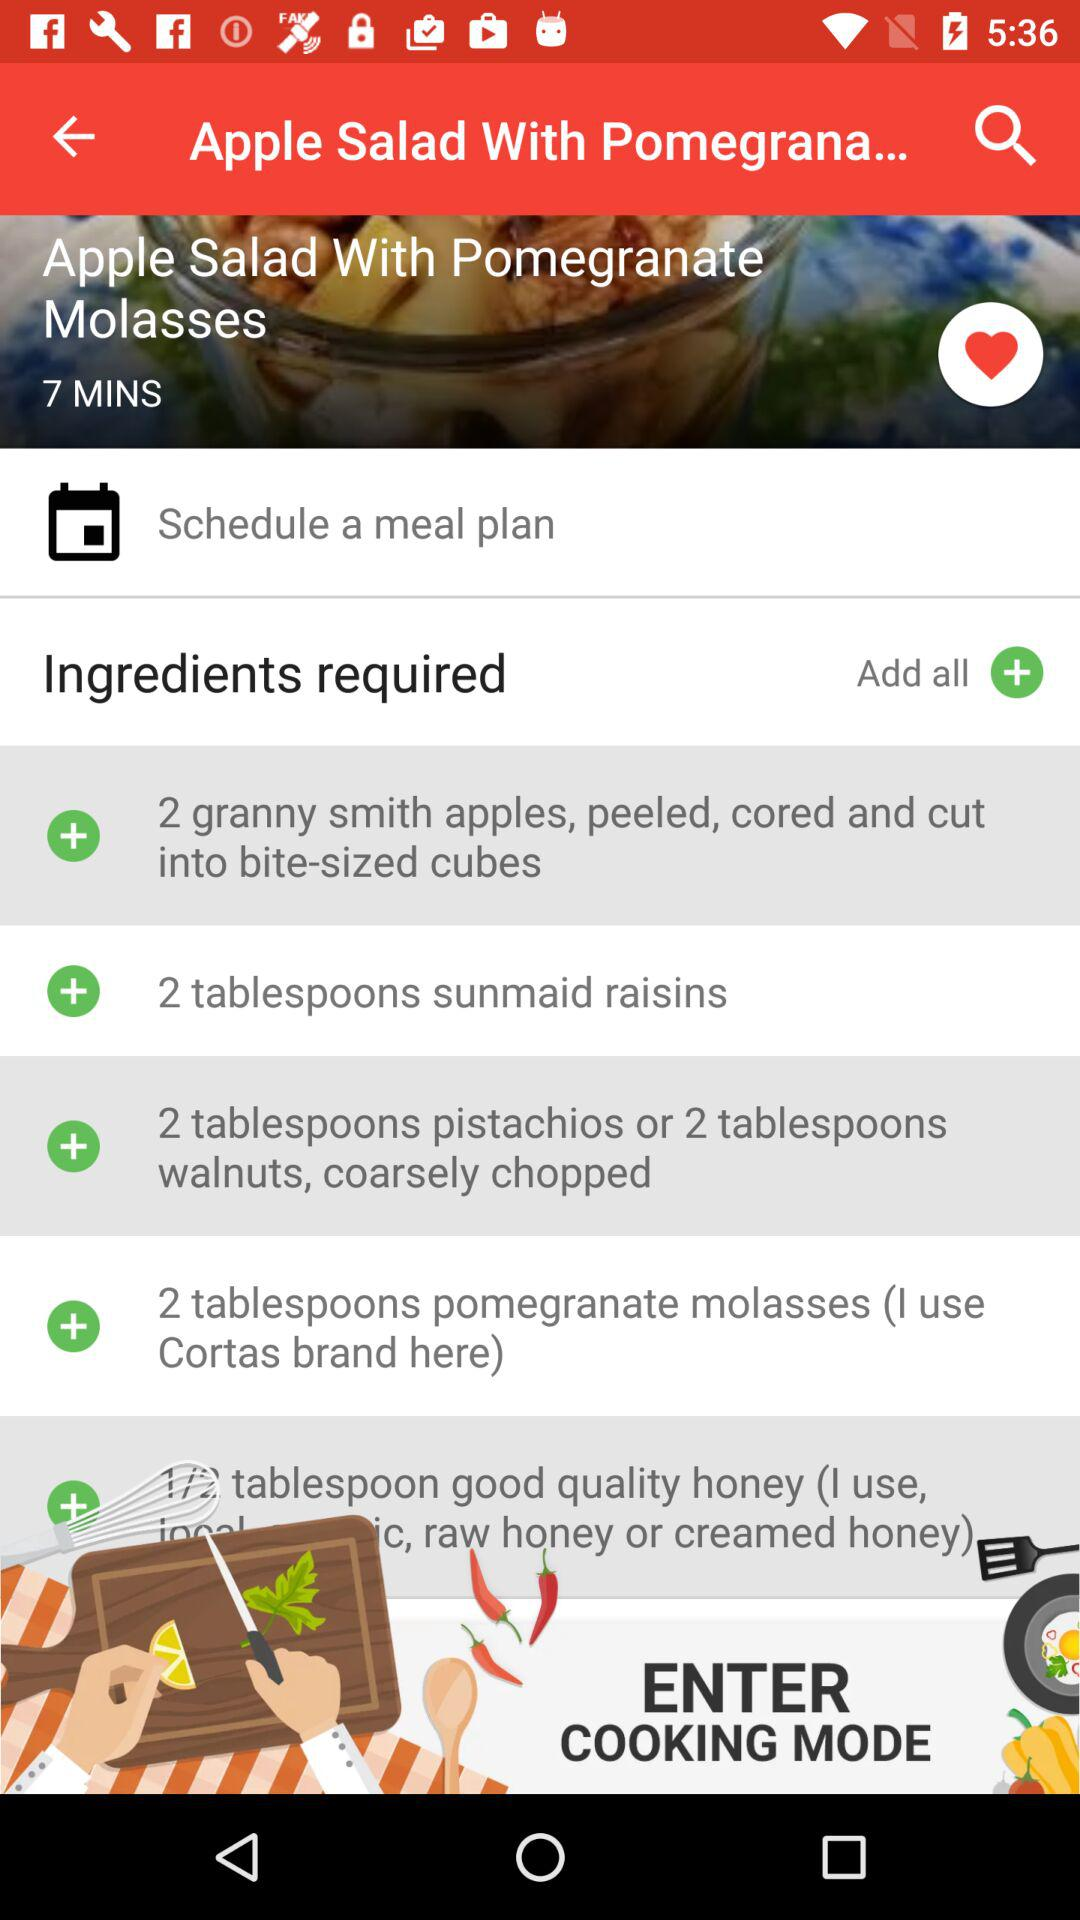Which types of honey are used by the poster?
When the provided information is insufficient, respond with <no answer>. <no answer> 